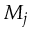Convert formula to latex. <formula><loc_0><loc_0><loc_500><loc_500>M _ { j }</formula> 